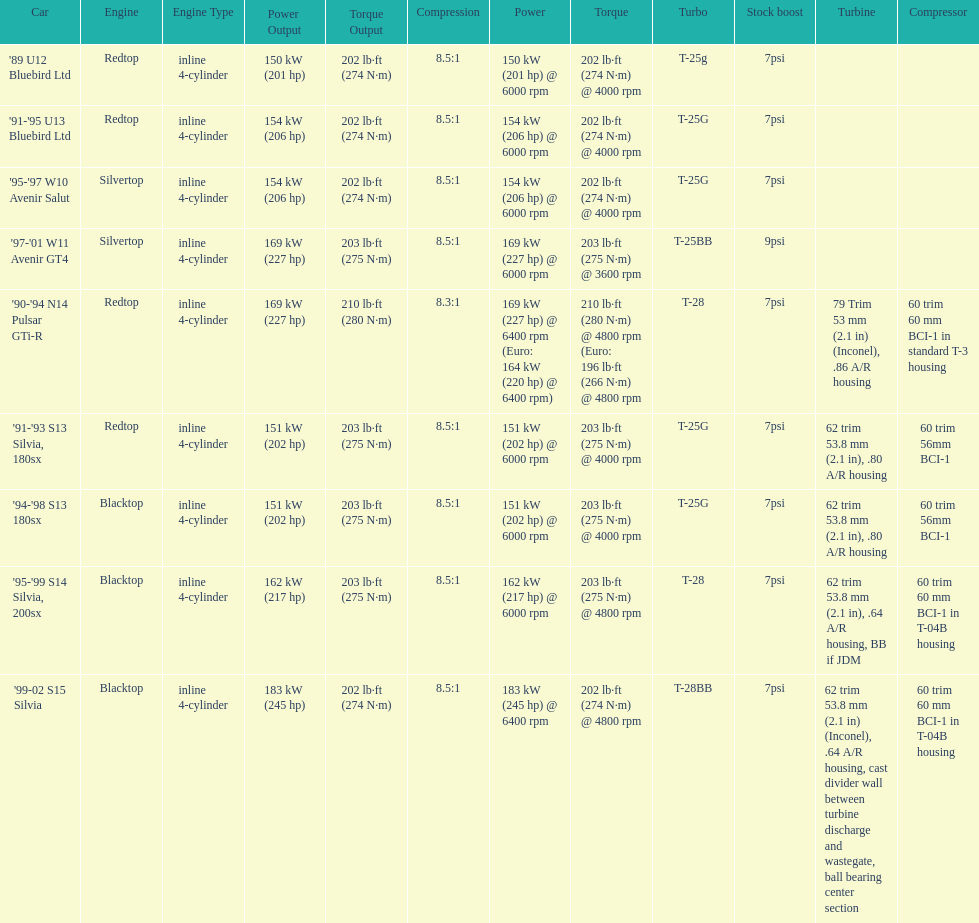Which engine(s) has the least amount of power? Redtop. 